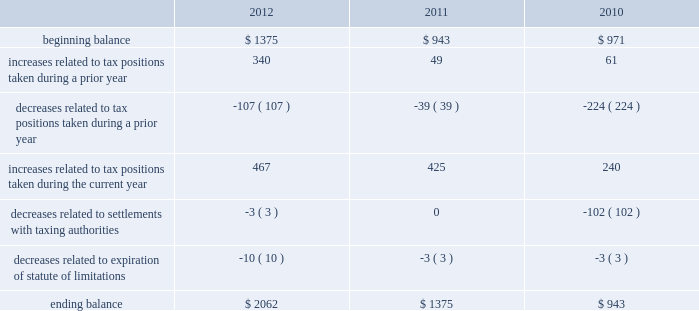The aggregate changes in the balance of gross unrecognized tax benefits , which excludes interest and penalties , for 2012 , 2011 , and 2010 , is as follows ( in millions ) : .
The company includes interest and penalties related to unrecognized tax benefits within the provision for income taxes .
As of september 29 , 2012 and september 24 , 2011 , the total amount of gross interest and penalties accrued was $ 401 million and $ 261 million , respectively , which is classified as non-current liabilities in the consolidated balance sheets .
In connection with tax matters , the company recognized interest expense in 2012 and 2011 of $ 140 million and $ 14 million , respectively , and in 2010 the company recognized an interest benefit of $ 43 million .
The company is subject to taxation and files income tax returns in the u.s .
Federal jurisdiction and in many state and foreign jurisdictions .
For u.s .
Federal income tax purposes , all years prior to 2004 are closed .
The internal revenue service ( the 201cirs 201d ) has completed its field audit of the company 2019s federal income tax returns for the years 2004 through 2006 and proposed certain adjustments .
The company has contested certain of these adjustments through the irs appeals office .
The irs is currently examining the years 2007 through 2009 .
In addition , the company is also subject to audits by state , local and foreign tax authorities .
In major states and major foreign jurisdictions , the years subsequent to 1989 and 2002 , respectively , generally remain open and could be subject to examination by the taxing authorities .
Management believes that an adequate provision has been made for any adjustments that may result from tax examinations .
However , the outcome of tax audits cannot be predicted with certainty .
If any issues addressed in the company 2019s tax audits are resolved in a manner not consistent with management 2019s expectations , the company could be required to adjust its provision for income tax in the period such resolution occurs .
Although timing of the resolution and/or closure of audits is not certain , the company believes it is reasonably possible that tax audit resolutions could reduce its unrecognized tax benefits by between $ 120 million and $ 170 million in the next 12 months .
Note 6 2013 shareholders 2019 equity and share-based compensation preferred stock the company has five million shares of authorized preferred stock , none of which is issued or outstanding .
Under the terms of the company 2019s restated articles of incorporation , the board of directors is authorized to determine or alter the rights , preferences , privileges and restrictions of the company 2019s authorized but unissued shares of preferred stock .
Dividend and stock repurchase program in 2012 , the board of directors of the company approved a dividend policy pursuant to which it plans to make , subject to subsequent declaration , quarterly dividends of $ 2.65 per share .
On july 24 , 2012 , the board of directors declared a dividend of $ 2.65 per share to shareholders of record as of the close of business on august 13 , 2012 .
The company paid $ 2.5 billion in conjunction with this dividend on august 16 , 2012 .
No dividends were declared in the first three quarters of 2012 or in 2011 and 2010. .
What was the aggregate change in the ending balance of gross unrecognized tax benefits , which excludes interest and penalties between 2012 and 2011? 
Computations: (2062 - 1375)
Answer: 687.0. The aggregate changes in the balance of gross unrecognized tax benefits , which excludes interest and penalties , for 2012 , 2011 , and 2010 , is as follows ( in millions ) : .
The company includes interest and penalties related to unrecognized tax benefits within the provision for income taxes .
As of september 29 , 2012 and september 24 , 2011 , the total amount of gross interest and penalties accrued was $ 401 million and $ 261 million , respectively , which is classified as non-current liabilities in the consolidated balance sheets .
In connection with tax matters , the company recognized interest expense in 2012 and 2011 of $ 140 million and $ 14 million , respectively , and in 2010 the company recognized an interest benefit of $ 43 million .
The company is subject to taxation and files income tax returns in the u.s .
Federal jurisdiction and in many state and foreign jurisdictions .
For u.s .
Federal income tax purposes , all years prior to 2004 are closed .
The internal revenue service ( the 201cirs 201d ) has completed its field audit of the company 2019s federal income tax returns for the years 2004 through 2006 and proposed certain adjustments .
The company has contested certain of these adjustments through the irs appeals office .
The irs is currently examining the years 2007 through 2009 .
In addition , the company is also subject to audits by state , local and foreign tax authorities .
In major states and major foreign jurisdictions , the years subsequent to 1989 and 2002 , respectively , generally remain open and could be subject to examination by the taxing authorities .
Management believes that an adequate provision has been made for any adjustments that may result from tax examinations .
However , the outcome of tax audits cannot be predicted with certainty .
If any issues addressed in the company 2019s tax audits are resolved in a manner not consistent with management 2019s expectations , the company could be required to adjust its provision for income tax in the period such resolution occurs .
Although timing of the resolution and/or closure of audits is not certain , the company believes it is reasonably possible that tax audit resolutions could reduce its unrecognized tax benefits by between $ 120 million and $ 170 million in the next 12 months .
Note 6 2013 shareholders 2019 equity and share-based compensation preferred stock the company has five million shares of authorized preferred stock , none of which is issued or outstanding .
Under the terms of the company 2019s restated articles of incorporation , the board of directors is authorized to determine or alter the rights , preferences , privileges and restrictions of the company 2019s authorized but unissued shares of preferred stock .
Dividend and stock repurchase program in 2012 , the board of directors of the company approved a dividend policy pursuant to which it plans to make , subject to subsequent declaration , quarterly dividends of $ 2.65 per share .
On july 24 , 2012 , the board of directors declared a dividend of $ 2.65 per share to shareholders of record as of the close of business on august 13 , 2012 .
The company paid $ 2.5 billion in conjunction with this dividend on august 16 , 2012 .
No dividends were declared in the first three quarters of 2012 or in 2011 and 2010. .
What was the percentage change in the gross unrecognized tax benefits between 2010 and 2011? 
Computations: ((1375 - 943) / 943)
Answer: 0.45811. The aggregate changes in the balance of gross unrecognized tax benefits , which excludes interest and penalties , for 2012 , 2011 , and 2010 , is as follows ( in millions ) : .
The company includes interest and penalties related to unrecognized tax benefits within the provision for income taxes .
As of september 29 , 2012 and september 24 , 2011 , the total amount of gross interest and penalties accrued was $ 401 million and $ 261 million , respectively , which is classified as non-current liabilities in the consolidated balance sheets .
In connection with tax matters , the company recognized interest expense in 2012 and 2011 of $ 140 million and $ 14 million , respectively , and in 2010 the company recognized an interest benefit of $ 43 million .
The company is subject to taxation and files income tax returns in the u.s .
Federal jurisdiction and in many state and foreign jurisdictions .
For u.s .
Federal income tax purposes , all years prior to 2004 are closed .
The internal revenue service ( the 201cirs 201d ) has completed its field audit of the company 2019s federal income tax returns for the years 2004 through 2006 and proposed certain adjustments .
The company has contested certain of these adjustments through the irs appeals office .
The irs is currently examining the years 2007 through 2009 .
In addition , the company is also subject to audits by state , local and foreign tax authorities .
In major states and major foreign jurisdictions , the years subsequent to 1989 and 2002 , respectively , generally remain open and could be subject to examination by the taxing authorities .
Management believes that an adequate provision has been made for any adjustments that may result from tax examinations .
However , the outcome of tax audits cannot be predicted with certainty .
If any issues addressed in the company 2019s tax audits are resolved in a manner not consistent with management 2019s expectations , the company could be required to adjust its provision for income tax in the period such resolution occurs .
Although timing of the resolution and/or closure of audits is not certain , the company believes it is reasonably possible that tax audit resolutions could reduce its unrecognized tax benefits by between $ 120 million and $ 170 million in the next 12 months .
Note 6 2013 shareholders 2019 equity and share-based compensation preferred stock the company has five million shares of authorized preferred stock , none of which is issued or outstanding .
Under the terms of the company 2019s restated articles of incorporation , the board of directors is authorized to determine or alter the rights , preferences , privileges and restrictions of the company 2019s authorized but unissued shares of preferred stock .
Dividend and stock repurchase program in 2012 , the board of directors of the company approved a dividend policy pursuant to which it plans to make , subject to subsequent declaration , quarterly dividends of $ 2.65 per share .
On july 24 , 2012 , the board of directors declared a dividend of $ 2.65 per share to shareholders of record as of the close of business on august 13 , 2012 .
The company paid $ 2.5 billion in conjunction with this dividend on august 16 , 2012 .
No dividends were declared in the first three quarters of 2012 or in 2011 and 2010. .
In connection with tax matters , what was the increase in recognized interest expense between 2012 and 2011? 
Computations: (140 - 140)
Answer: 0.0. 